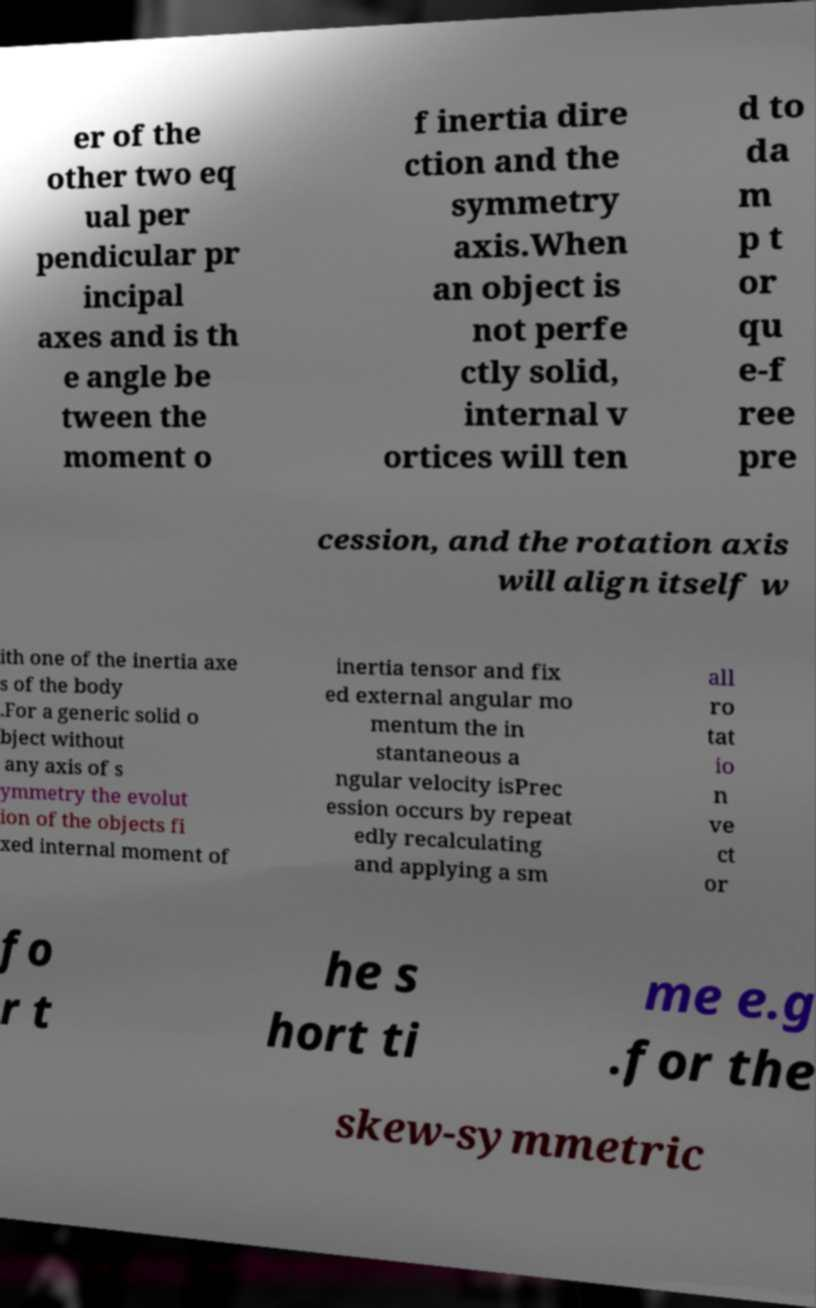Could you extract and type out the text from this image? er of the other two eq ual per pendicular pr incipal axes and is th e angle be tween the moment o f inertia dire ction and the symmetry axis.When an object is not perfe ctly solid, internal v ortices will ten d to da m p t or qu e-f ree pre cession, and the rotation axis will align itself w ith one of the inertia axe s of the body .For a generic solid o bject without any axis of s ymmetry the evolut ion of the objects fi xed internal moment of inertia tensor and fix ed external angular mo mentum the in stantaneous a ngular velocity isPrec ession occurs by repeat edly recalculating and applying a sm all ro tat io n ve ct or fo r t he s hort ti me e.g .for the skew-symmetric 